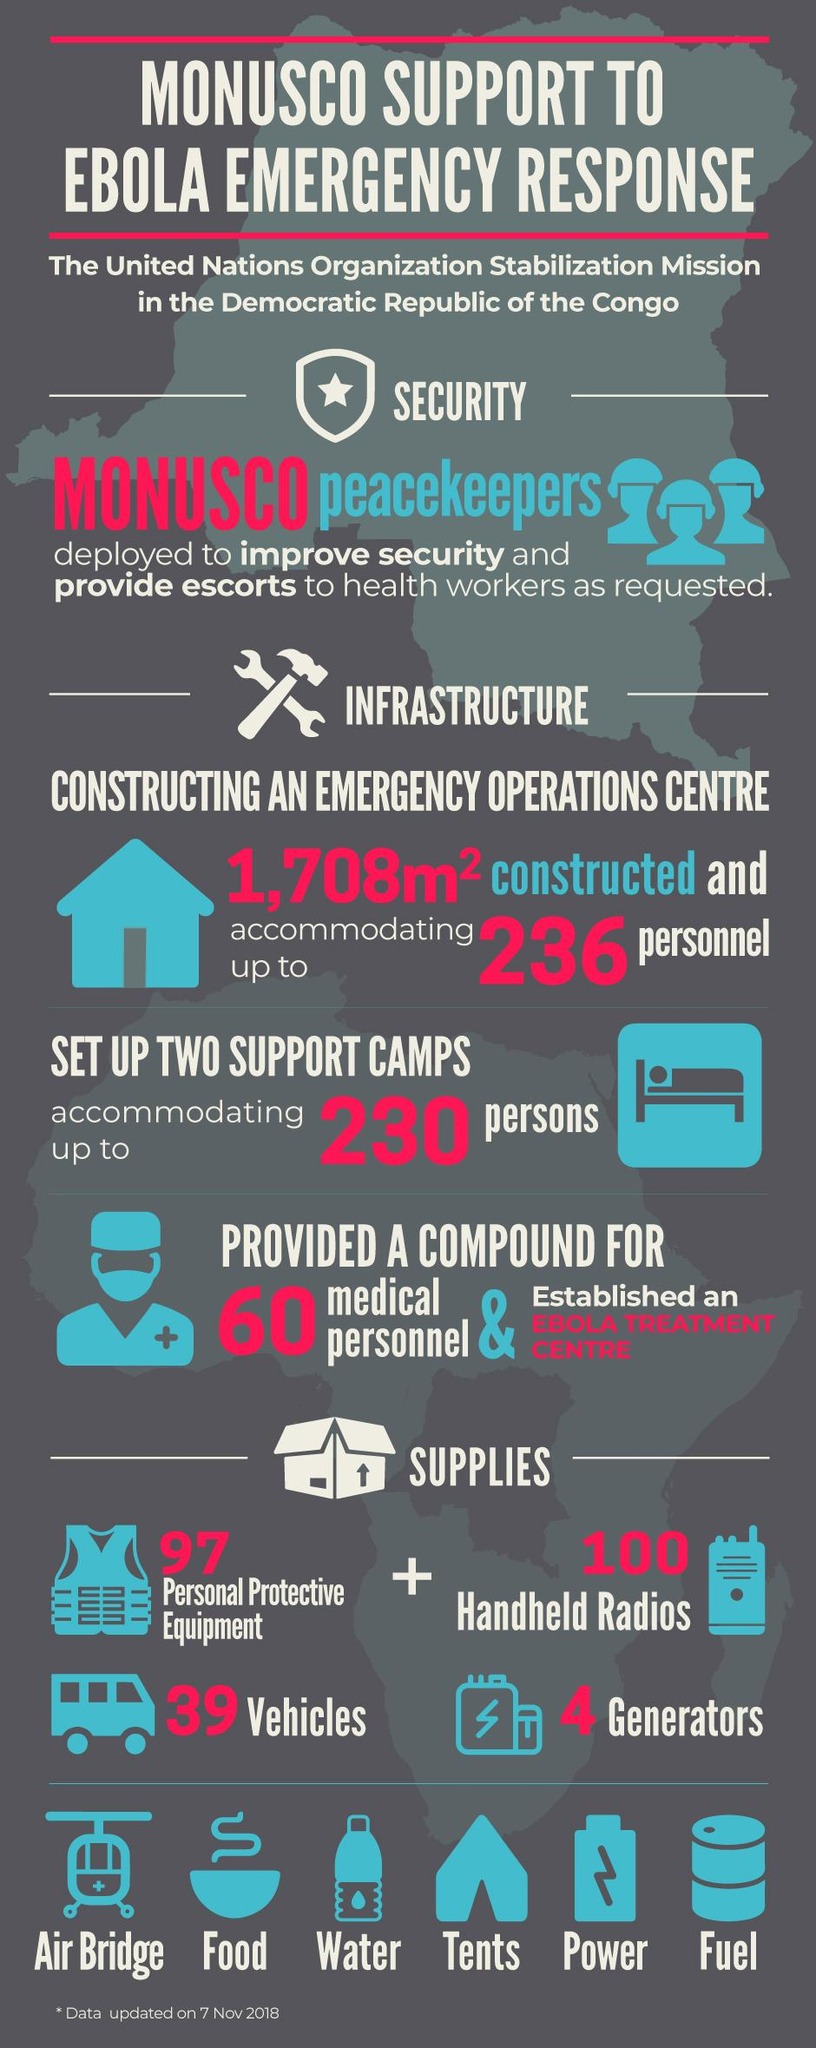Identify some key points in this picture. During the Ebola emergency response, a total of 240 supplies were provided to support the response efforts. 